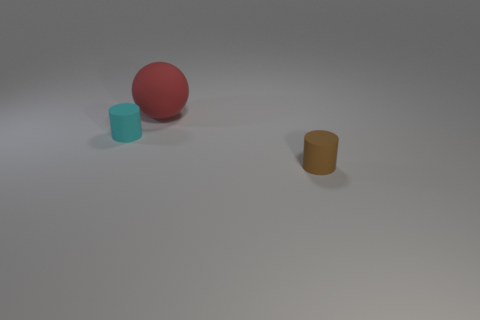Is there anything indicating the scale or size of these objects? There are no direct references in the image for scale comparison. However, judging by the shadows and lighting, they appear to be small enough to fit comfortably in one's hand. What about the textures of the objects; how would you describe them? The textures of the objects appear smooth and matte, which could suggest they are made out of plastic or a similar material. 